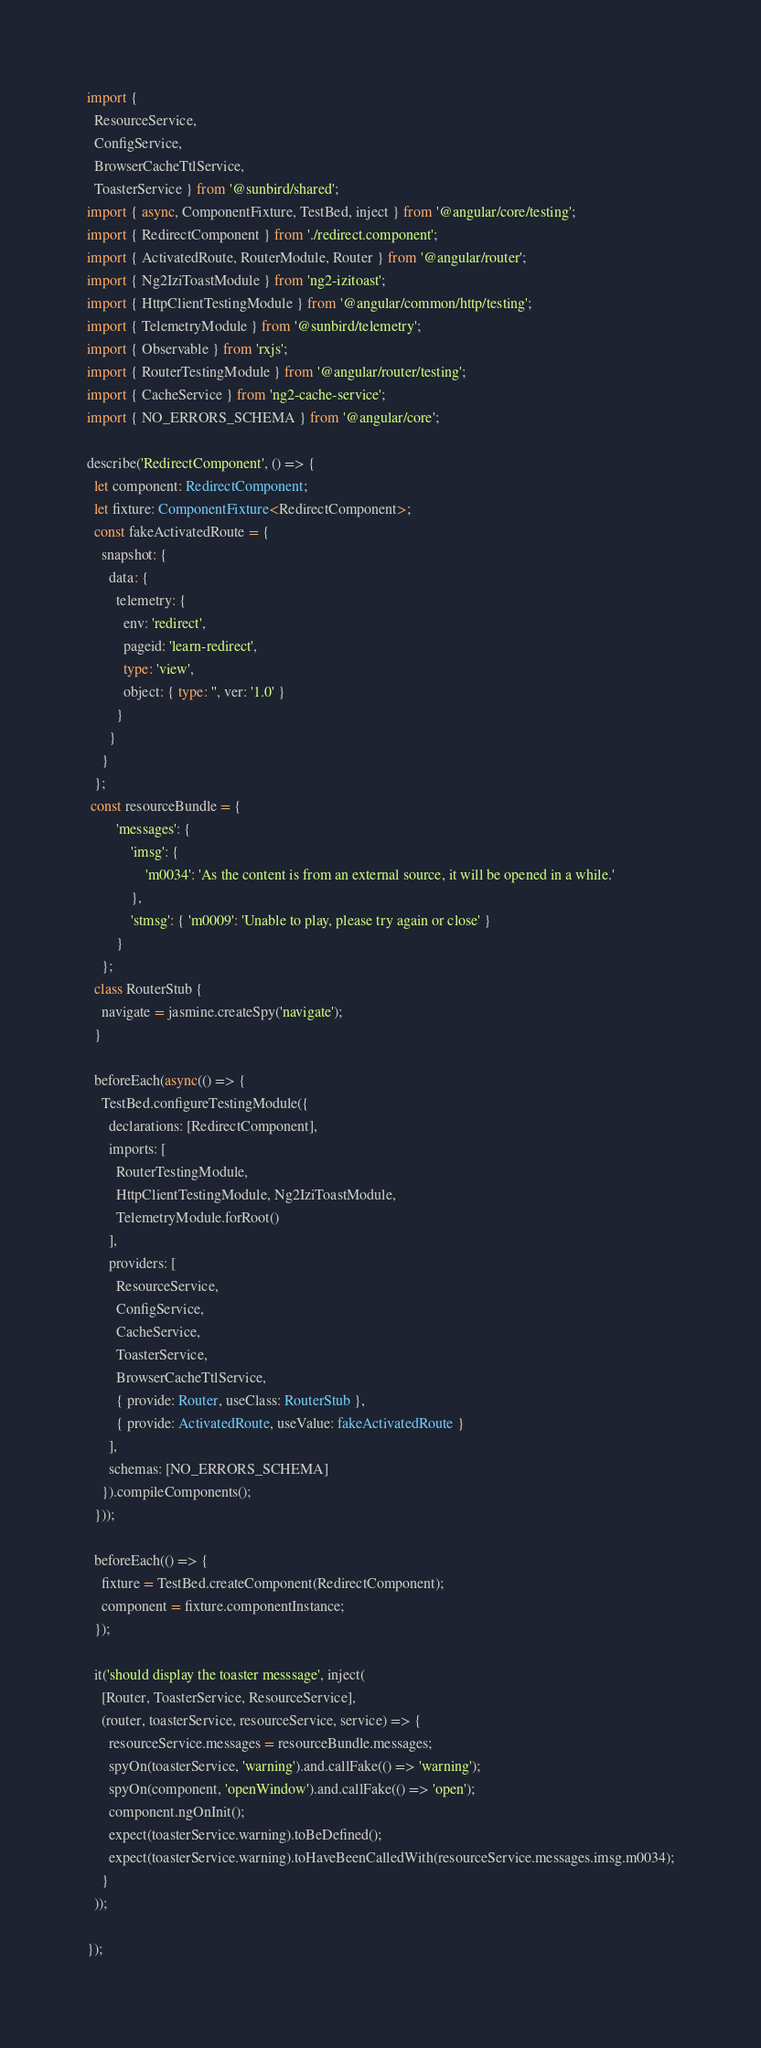Convert code to text. <code><loc_0><loc_0><loc_500><loc_500><_TypeScript_>import {
  ResourceService,
  ConfigService,
  BrowserCacheTtlService,
  ToasterService } from '@sunbird/shared';
import { async, ComponentFixture, TestBed, inject } from '@angular/core/testing';
import { RedirectComponent } from './redirect.component';
import { ActivatedRoute, RouterModule, Router } from '@angular/router';
import { Ng2IziToastModule } from 'ng2-izitoast';
import { HttpClientTestingModule } from '@angular/common/http/testing';
import { TelemetryModule } from '@sunbird/telemetry';
import { Observable } from 'rxjs';
import { RouterTestingModule } from '@angular/router/testing';
import { CacheService } from 'ng2-cache-service';
import { NO_ERRORS_SCHEMA } from '@angular/core';

describe('RedirectComponent', () => {
  let component: RedirectComponent;
  let fixture: ComponentFixture<RedirectComponent>;
  const fakeActivatedRoute = {
    snapshot: {
      data: {
        telemetry: {
          env: 'redirect',
          pageid: 'learn-redirect',
          type: 'view',
          object: { type: '', ver: '1.0' }
        }
      }
    }
  };
 const resourceBundle = {
        'messages': {
            'imsg': {
                'm0034': 'As the content is from an external source, it will be opened in a while.'
            },
            'stmsg': { 'm0009': 'Unable to play, please try again or close' }
        }
    };
  class RouterStub {
    navigate = jasmine.createSpy('navigate');
  }

  beforeEach(async(() => {
    TestBed.configureTestingModule({
      declarations: [RedirectComponent],
      imports: [
        RouterTestingModule,
        HttpClientTestingModule, Ng2IziToastModule,
        TelemetryModule.forRoot()
      ],
      providers: [
        ResourceService,
        ConfigService,
        CacheService,
        ToasterService,
        BrowserCacheTtlService,
        { provide: Router, useClass: RouterStub },
        { provide: ActivatedRoute, useValue: fakeActivatedRoute }
      ],
      schemas: [NO_ERRORS_SCHEMA]
    }).compileComponents();
  }));

  beforeEach(() => {
    fixture = TestBed.createComponent(RedirectComponent);
    component = fixture.componentInstance;
  });

  it('should display the toaster messsage', inject(
    [Router, ToasterService, ResourceService],
    (router, toasterService, resourceService, service) => {
      resourceService.messages = resourceBundle.messages;
      spyOn(toasterService, 'warning').and.callFake(() => 'warning');
      spyOn(component, 'openWindow').and.callFake(() => 'open');
      component.ngOnInit();
      expect(toasterService.warning).toBeDefined();
      expect(toasterService.warning).toHaveBeenCalledWith(resourceService.messages.imsg.m0034);
    }
  ));

});

</code> 